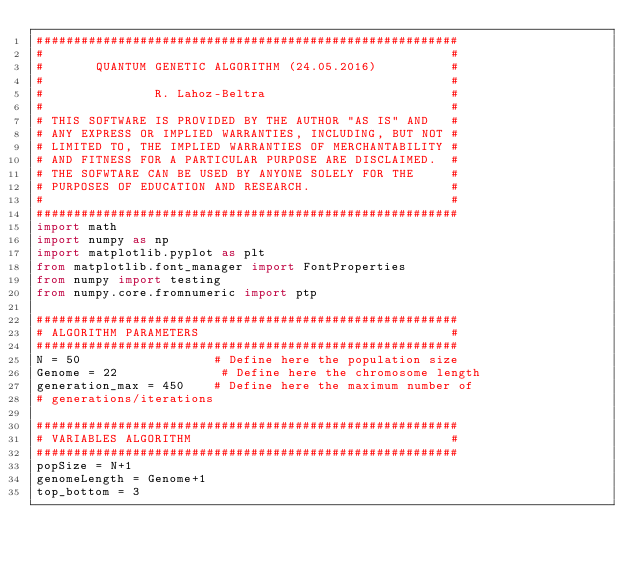Convert code to text. <code><loc_0><loc_0><loc_500><loc_500><_Python_>#########################################################
#                                                       #
#       QUANTUM GENETIC ALGORITHM (24.05.2016)          #
#                                                       #
#               R. Lahoz-Beltra                         #
#                                                       #
# THIS SOFTWARE IS PROVIDED BY THE AUTHOR "AS IS" AND   #
# ANY EXPRESS OR IMPLIED WARRANTIES, INCLUDING, BUT NOT #
# LIMITED TO, THE IMPLIED WARRANTIES OF MERCHANTABILITY #
# AND FITNESS FOR A PARTICULAR PURPOSE ARE DISCLAIMED.  #
# THE SOFWTARE CAN BE USED BY ANYONE SOLELY FOR THE     #
# PURPOSES OF EDUCATION AND RESEARCH.                   #
#                                                       #
#########################################################
import math
import numpy as np
import matplotlib.pyplot as plt
from matplotlib.font_manager import FontProperties
from numpy import testing
from numpy.core.fromnumeric import ptp

#########################################################
# ALGORITHM PARAMETERS                                  #
#########################################################
N = 50                  # Define here the population size
Genome = 22              # Define here the chromosome length
generation_max = 450    # Define here the maximum number of
# generations/iterations

#########################################################
# VARIABLES ALGORITHM                                   #
#########################################################
popSize = N+1
genomeLength = Genome+1
top_bottom = 3</code> 